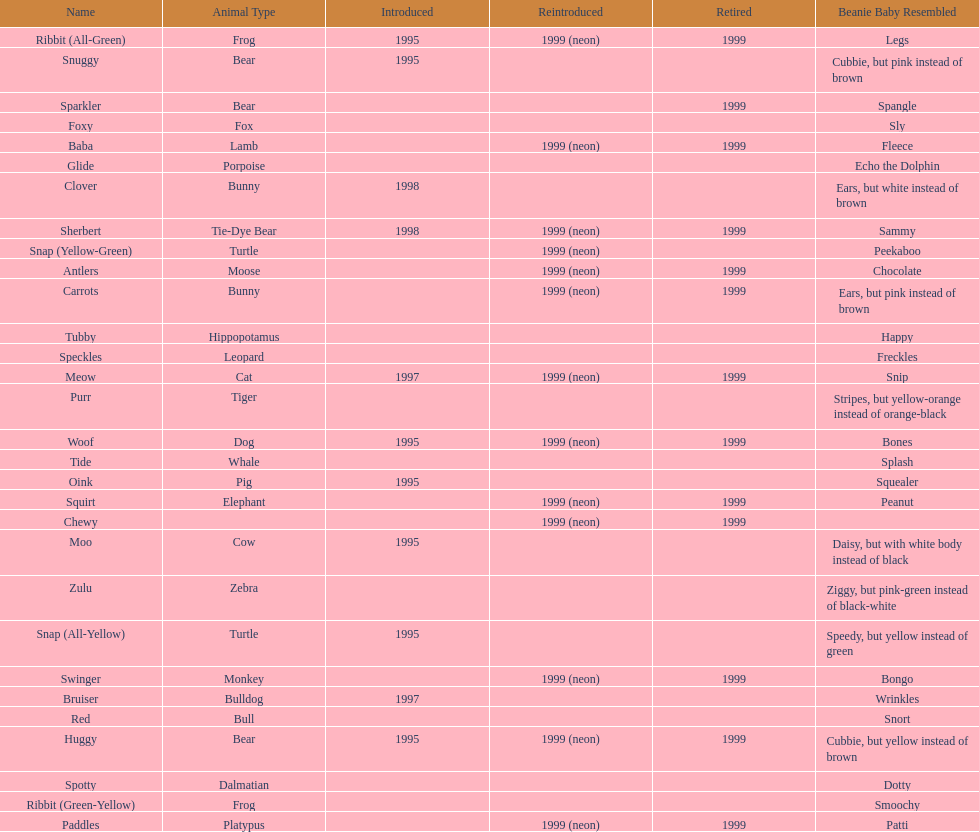Tell me the number of pillow pals reintroduced in 1999. 13. 